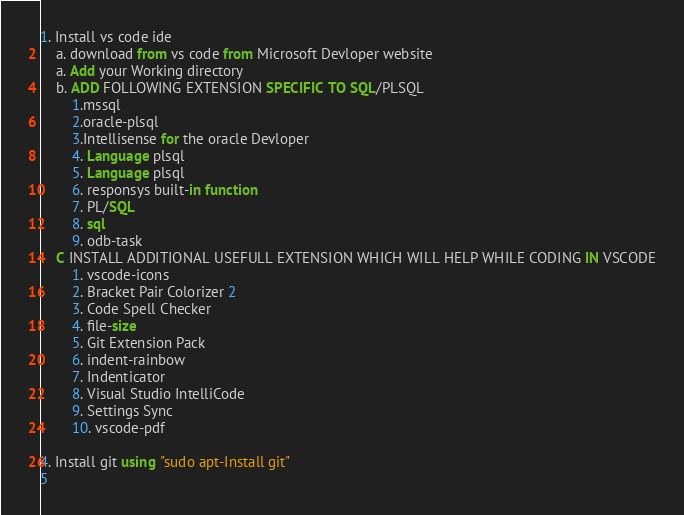<code> <loc_0><loc_0><loc_500><loc_500><_SQL_>1. Install vs code ide
    a. download from vs code from Microsoft Devloper website
    a. Add your Working directory
    b. ADD FOLLOWING EXTENSION SPECIFIC TO SQL/PLSQL
        1.mssql
        2.oracle-plsql
        3.Intellisense for the oracle Devloper
        4. Language plsql
        5. Language plsql
        6. responsys built-in function
        7. PL/SQL
        8. sql
        9. odb-task
    C INSTALL ADDITIONAL USEFULL EXTENSION WHICH WILL HELP WHILE CODING IN VSCODE
        1. vscode-icons
        2. Bracket Pair Colorizer 2
        3. Code Spell Checker
        4. file-size
        5. Git Extension Pack
        6. indent-rainbow
        7. Indenticator
        8. Visual Studio IntelliCode
        9. Settings Sync
        10. vscode-pdf

4. Install git using "sudo apt-Install git"
5
</code> 